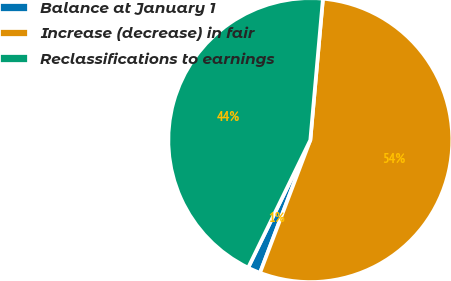<chart> <loc_0><loc_0><loc_500><loc_500><pie_chart><fcel>Balance at January 1<fcel>Increase (decrease) in fair<fcel>Reclassifications to earnings<nl><fcel>1.45%<fcel>54.35%<fcel>44.2%<nl></chart> 